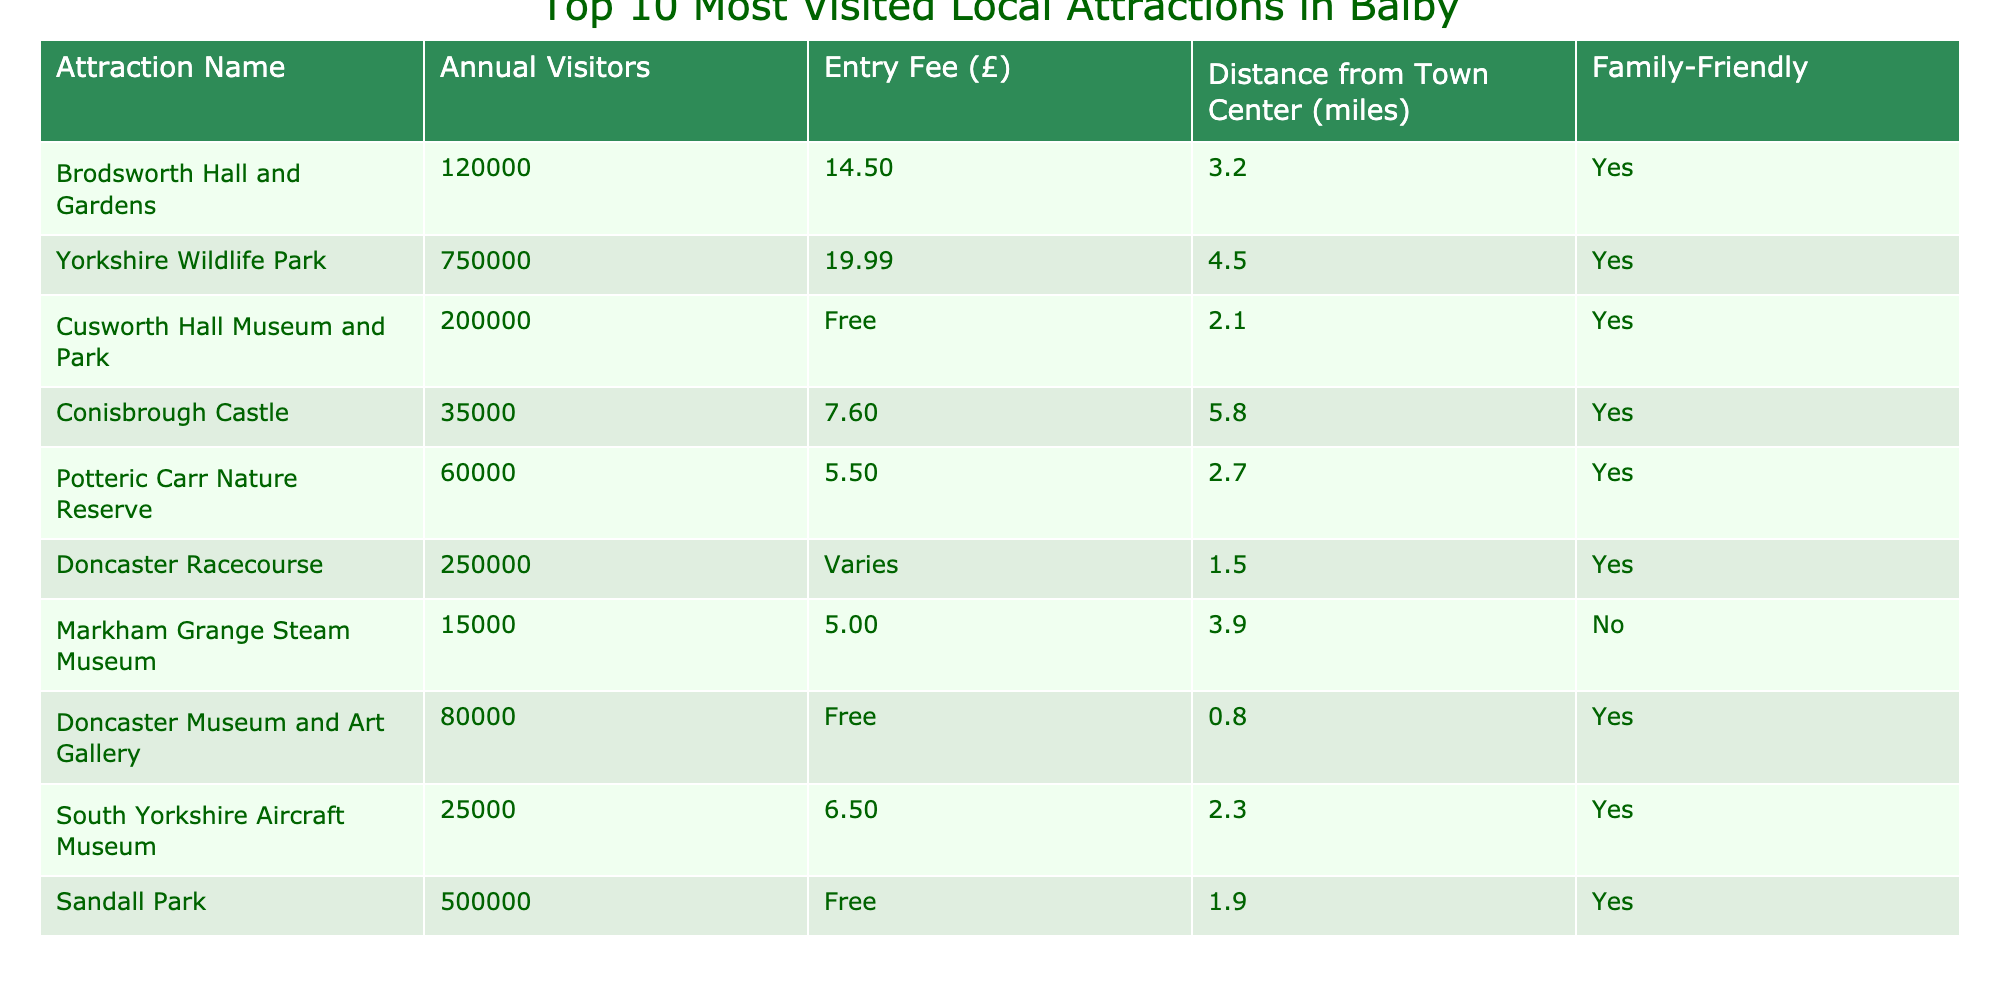What is the most visited local attraction in Balby? The table indicates that Yorkshire Wildlife Park has the highest number of annual visitors at 750,000.
Answer: Yorkshire Wildlife Park How many annual visitors does Doncaster Museum and Art Gallery have? According to the table, Doncaster Museum and Art Gallery has 80,000 annual visitors listed.
Answer: 80,000 Which attraction has an entry fee of £14.50? From the table, Brodsworth Hall and Gardens is noted to have an entry fee of £14.50.
Answer: Brodsworth Hall and Gardens Is Sandall Park family-friendly? The table states that Sandall Park is categorized as family-friendly.
Answer: Yes What is the average entry fee of attractions that have an entry fee listed? The entry fees that have values are £14.50, £19.99, £7.60, £5.50, £6.50, and £5.00. The sum is £54.09 and there are 6 attractions, which makes the average £54.09 / 6 ≈ £9.01.
Answer: Approximately £9.01 How many attractions are located within 2 miles of the town center? By checking the distances in the table, Doncaster Racecourse (1.5 miles), Doncaster Museum and Art Gallery (0.8 miles), Sandall Park (1.9 miles), and Cusworth Hall Museum and Park (2.1 miles) make a total of 4 attractions (with 3 under 2 miles).
Answer: 3 attractions What is the total number of visitors for family-friendly attractions? Summing the annual visitors of all family-friendly attractions (120,000 + 750,000 + 200,000 + 35,000 + 60,000 + 250,000 + 80,000 + 25,000 + 500,000) gives a total of 2,020,000 annual visitors for family-friendly attractions.
Answer: 2,020,000 Which attraction is furthest from the town center, and how far is it? Conisbrough Castle is listed with a distance of 5.8 miles, making it the furthest attraction according to the table.
Answer: Conisbrough Castle, 5.8 miles How many attractions have an entry fee of less than £10? The attractions with entry fees less than £10 are Conisbrough Castle (£7.60), Potteric Carr Nature Reserve (£5.50), Markham Grange Steam Museum (£5.00), and South Yorkshire Aircraft Museum (£6.50). This totals to 4 attractions with fees below £10.
Answer: 4 attractions Is there any attraction that does not have an entry fee? The table shows that Cusworth Hall Museum and Park, Doncaster Museum and Art Gallery, and Sandall Park are stated to have no entry fee.
Answer: Yes 